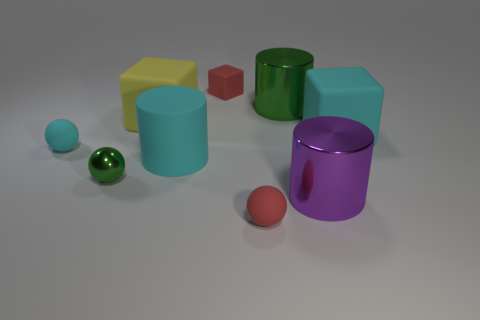The cube that is the same color as the large rubber cylinder is what size?
Ensure brevity in your answer.  Large. Are there any big purple cylinders made of the same material as the small green ball?
Provide a succinct answer. Yes. Are there the same number of tiny spheres that are right of the cyan block and big yellow cubes that are in front of the big yellow matte object?
Give a very brief answer. Yes. How big is the rubber thing that is to the left of the tiny green sphere?
Make the answer very short. Small. There is a green thing that is in front of the small rubber object to the left of the rubber cylinder; what is its material?
Offer a terse response. Metal. There is a small matte cube on the right side of the big cyan object to the left of the small rubber block; what number of purple metallic objects are on the right side of it?
Your answer should be compact. 1. Is the material of the block that is left of the small red rubber cube the same as the green thing right of the tiny rubber cube?
Provide a succinct answer. No. What material is the big cylinder that is the same color as the shiny sphere?
Offer a terse response. Metal. What number of small red rubber things are the same shape as the tiny cyan object?
Offer a very short reply. 1. Is the number of large cyan matte cylinders to the left of the big green object greater than the number of big red metallic blocks?
Make the answer very short. Yes. 